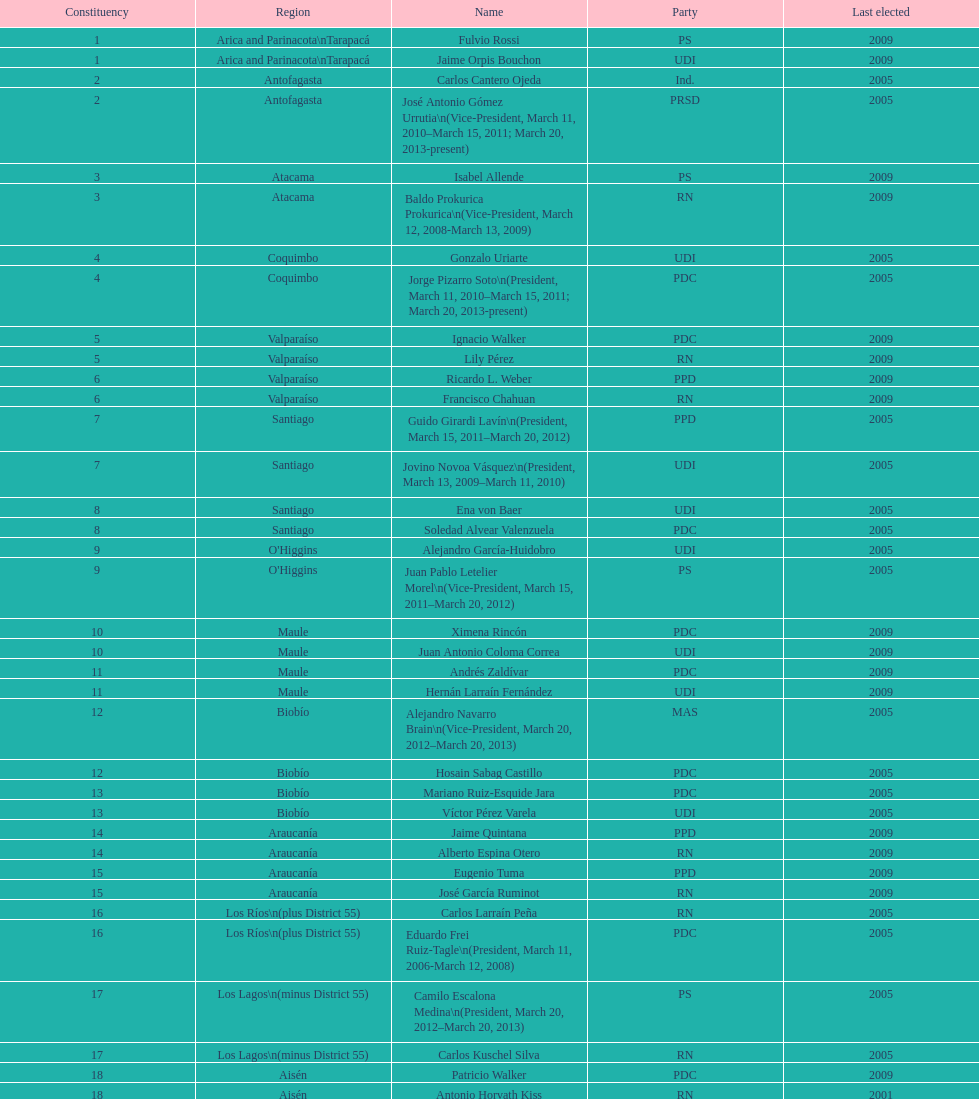What was the duration of baldo prokurica's tenure as vice-president? 1 year. 